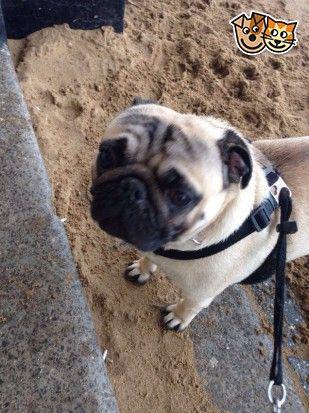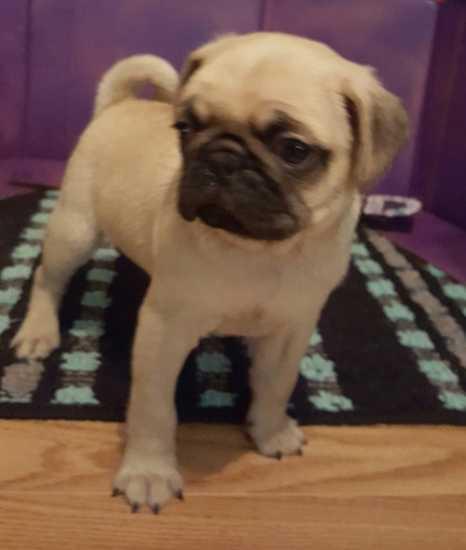The first image is the image on the left, the second image is the image on the right. For the images displayed, is the sentence "A dog in one of the images is sitting in the grass." factually correct? Answer yes or no. No. The first image is the image on the left, the second image is the image on the right. Assess this claim about the two images: "All dogs are shown on green grass, and no dog is in an action pose.". Correct or not? Answer yes or no. No. 